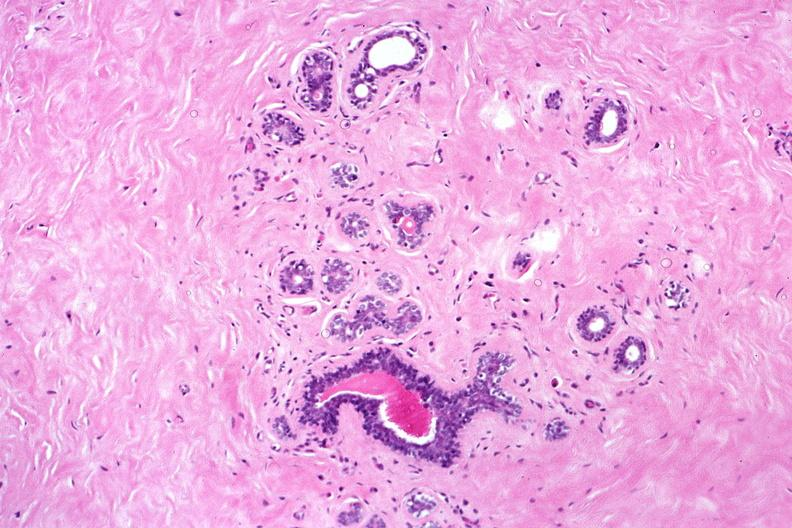what is present?
Answer the question using a single word or phrase. Female reproductive 